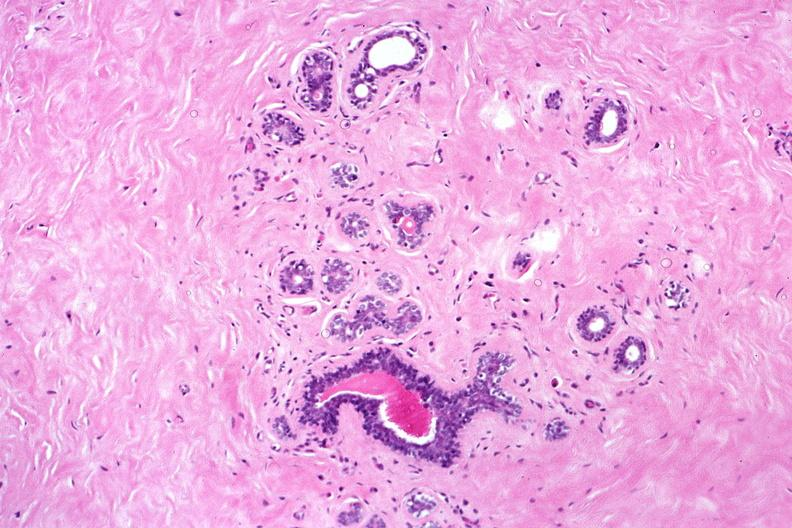what is present?
Answer the question using a single word or phrase. Female reproductive 